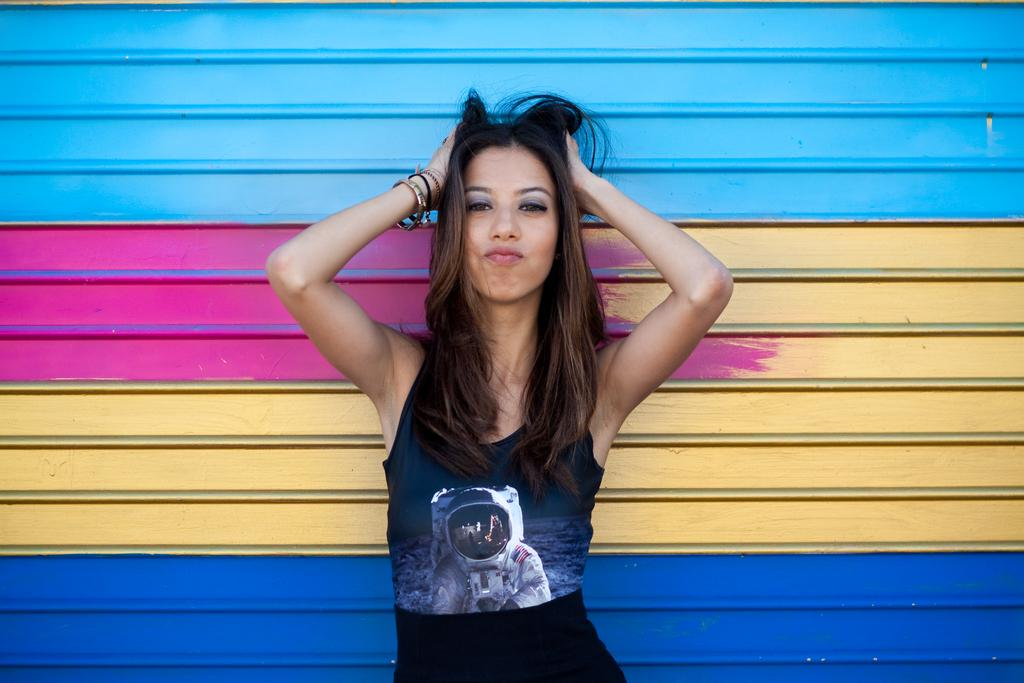Who is the main subject in the image? There is a woman in the image. What is the woman wearing on her upper body? The woman is wearing a blue top. What is the woman wearing on her lower body? The woman is wearing black trousers. What can be seen in the background of the image? There is a wall with different colors in the background of the image. What type of calculator is the woman using in the image? There is no calculator present in the image. What topic is the woman discussing with someone in the image? There is no discussion or other person visible in the image; it only features the woman. 